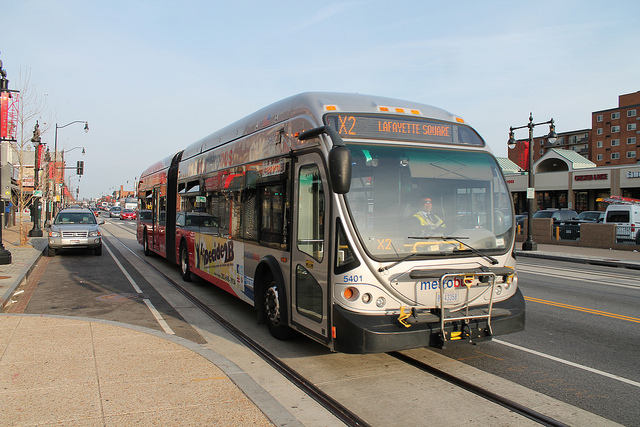How many clouds are in the picture? Upon reviewing the image, it's noticeable that the sky is clear and there are no clouds visible. 